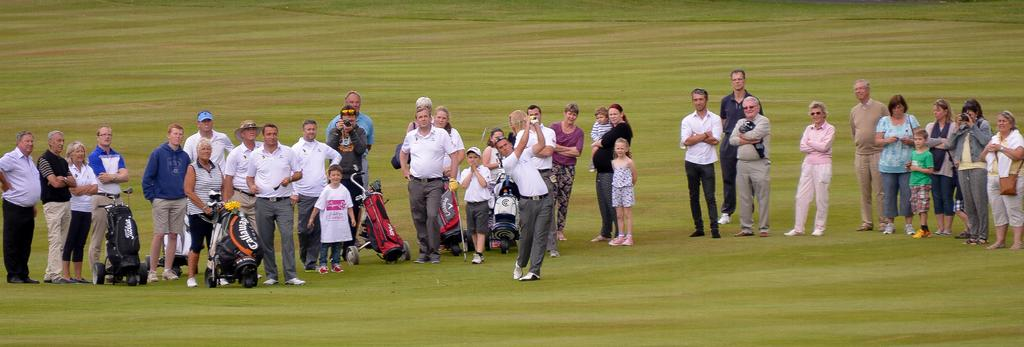How many people are in the image? There are people in the image, but the exact number is not specified. What are some people doing in the image? Some people are holding objects in the image. What can be seen on the ground in the image? The ground is visible in the image, and there is grass on it. What is the trolley with bags on it used for in the image? The trolley with bags on it is likely used for carrying or transporting items in the image. What channel is the television set to in the image? There is no television set present in the image. How many fingers does the person in the image have? The number of fingers a person has cannot be determined from the image alone, as it is not mentioned in the facts. 